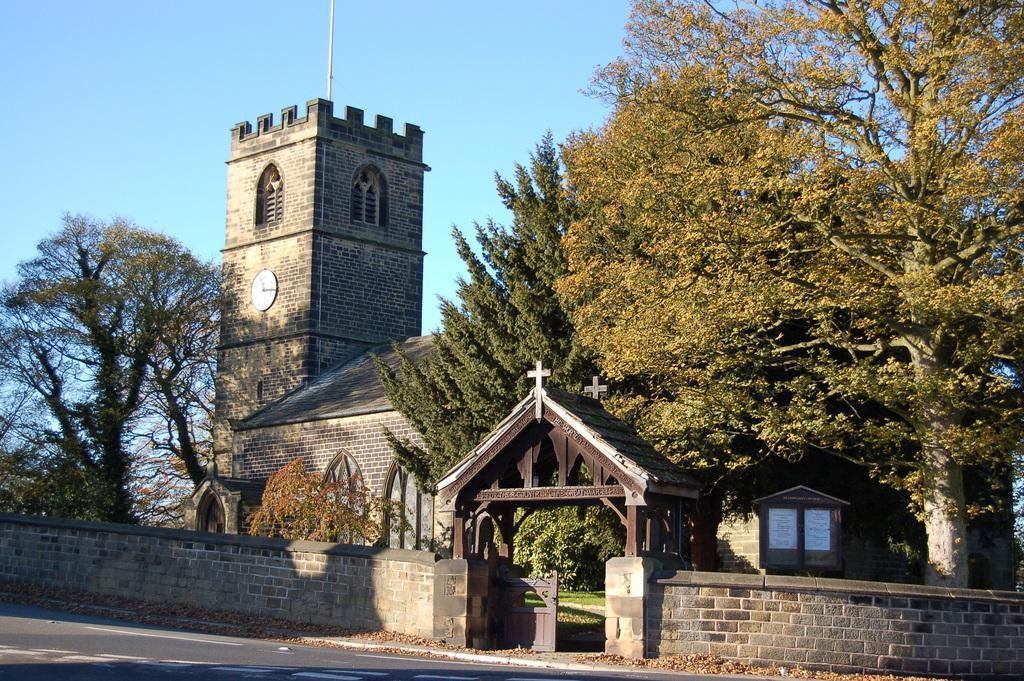Please provide a concise description of this image. In this image we can see a building with windows and doors. We can also see a clock on the wall, a cross on an arch, a gate and a wall. We can also see the pathway, a group of trees, a pole and the sky which looks cloudy. 